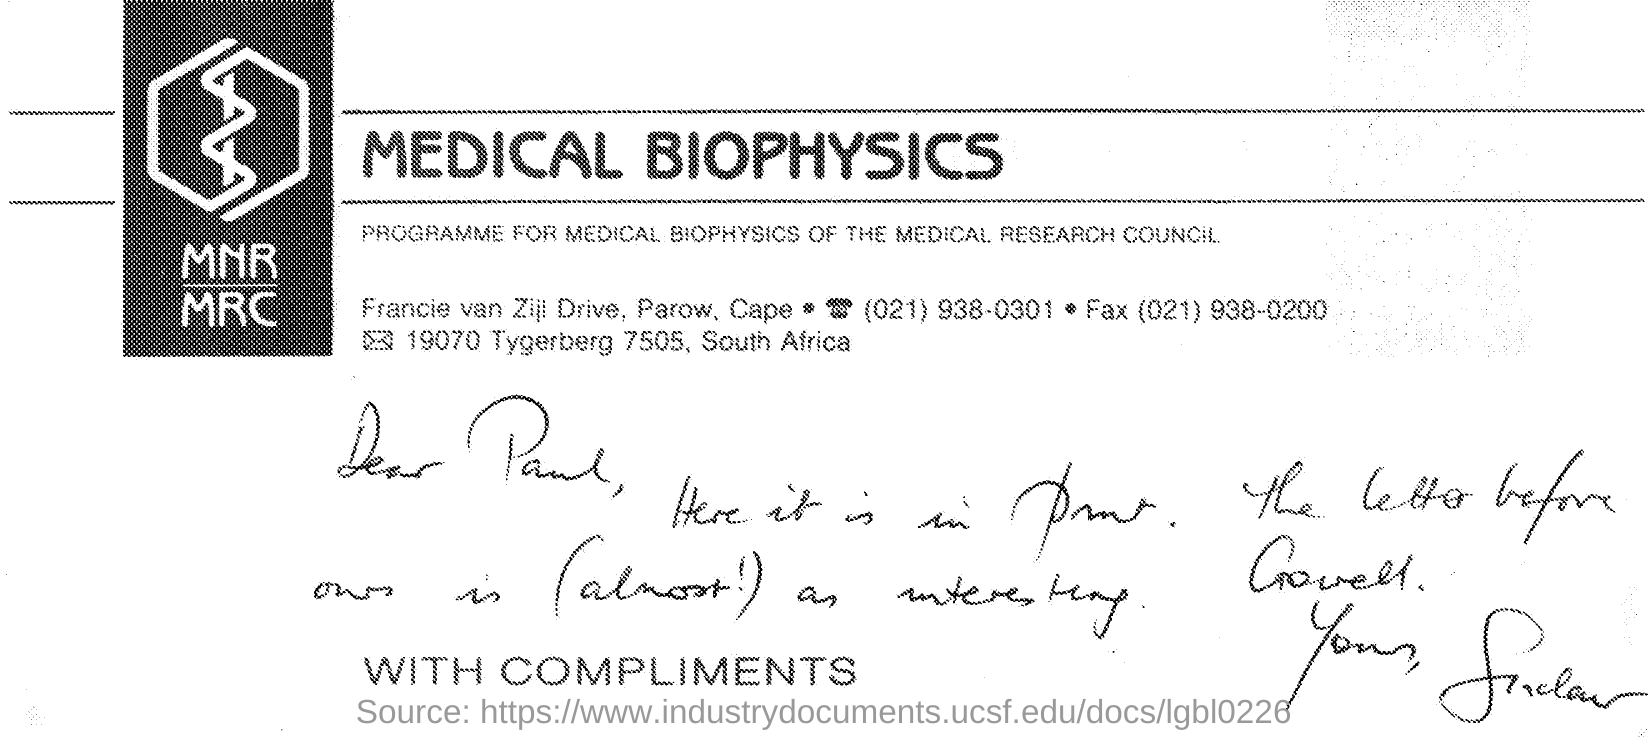Highlight a few significant elements in this photo. The title of the document is Medical Biophysics. The person mentioned as dear in the letter is Paul. 